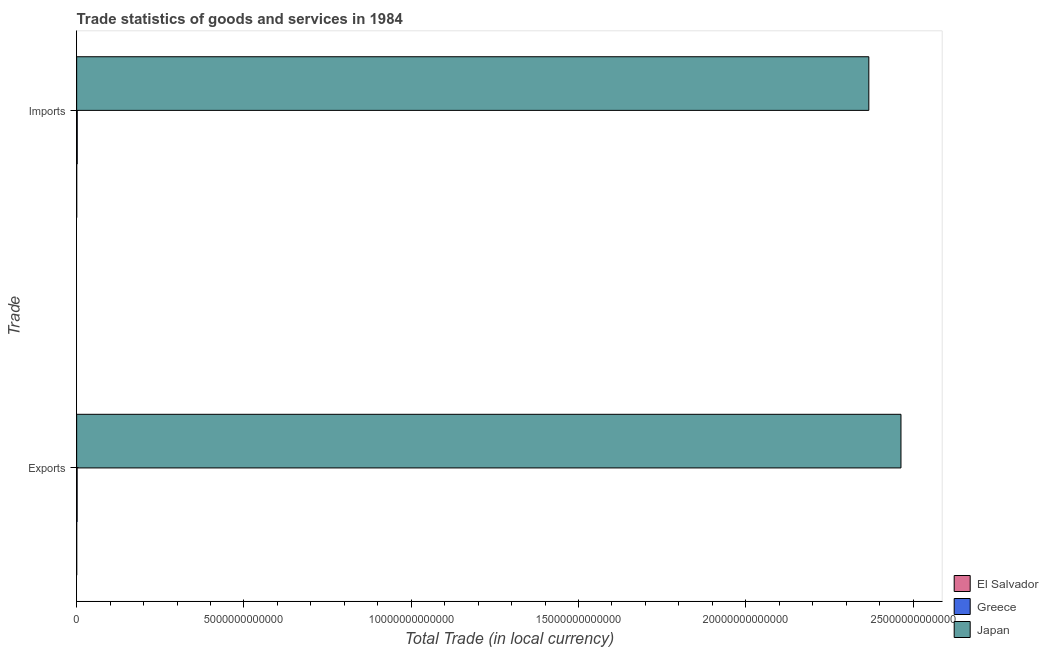How many groups of bars are there?
Offer a terse response. 2. How many bars are there on the 1st tick from the bottom?
Offer a very short reply. 3. What is the label of the 2nd group of bars from the top?
Make the answer very short. Exports. What is the export of goods and services in Greece?
Give a very brief answer. 1.41e+1. Across all countries, what is the maximum imports of goods and services?
Your answer should be very brief. 2.37e+13. Across all countries, what is the minimum imports of goods and services?
Offer a very short reply. 1.04e+09. In which country was the export of goods and services minimum?
Ensure brevity in your answer.  El Salvador. What is the total imports of goods and services in the graph?
Provide a short and direct response. 2.37e+13. What is the difference between the imports of goods and services in El Salvador and that in Greece?
Provide a succinct answer. -1.61e+1. What is the difference between the imports of goods and services in Greece and the export of goods and services in El Salvador?
Keep it short and to the point. 1.62e+1. What is the average export of goods and services per country?
Make the answer very short. 8.22e+12. What is the difference between the imports of goods and services and export of goods and services in Greece?
Your response must be concise. 3.04e+09. What is the ratio of the export of goods and services in Japan to that in El Salvador?
Make the answer very short. 2.49e+04. Is the imports of goods and services in Japan less than that in Greece?
Give a very brief answer. No. In how many countries, is the export of goods and services greater than the average export of goods and services taken over all countries?
Keep it short and to the point. 1. What does the 2nd bar from the top in Exports represents?
Give a very brief answer. Greece. What does the 1st bar from the bottom in Exports represents?
Your answer should be compact. El Salvador. How many countries are there in the graph?
Your answer should be very brief. 3. What is the difference between two consecutive major ticks on the X-axis?
Provide a short and direct response. 5.00e+12. Are the values on the major ticks of X-axis written in scientific E-notation?
Make the answer very short. No. How many legend labels are there?
Provide a succinct answer. 3. What is the title of the graph?
Ensure brevity in your answer.  Trade statistics of goods and services in 1984. Does "Congo (Democratic)" appear as one of the legend labels in the graph?
Make the answer very short. No. What is the label or title of the X-axis?
Offer a very short reply. Total Trade (in local currency). What is the label or title of the Y-axis?
Give a very brief answer. Trade. What is the Total Trade (in local currency) in El Salvador in Exports?
Make the answer very short. 9.90e+08. What is the Total Trade (in local currency) of Greece in Exports?
Offer a very short reply. 1.41e+1. What is the Total Trade (in local currency) in Japan in Exports?
Your answer should be very brief. 2.46e+13. What is the Total Trade (in local currency) of El Salvador in Imports?
Your answer should be very brief. 1.04e+09. What is the Total Trade (in local currency) of Greece in Imports?
Provide a short and direct response. 1.71e+1. What is the Total Trade (in local currency) of Japan in Imports?
Ensure brevity in your answer.  2.37e+13. Across all Trade, what is the maximum Total Trade (in local currency) in El Salvador?
Your response must be concise. 1.04e+09. Across all Trade, what is the maximum Total Trade (in local currency) of Greece?
Make the answer very short. 1.71e+1. Across all Trade, what is the maximum Total Trade (in local currency) in Japan?
Your answer should be compact. 2.46e+13. Across all Trade, what is the minimum Total Trade (in local currency) of El Salvador?
Your answer should be very brief. 9.90e+08. Across all Trade, what is the minimum Total Trade (in local currency) of Greece?
Make the answer very short. 1.41e+1. Across all Trade, what is the minimum Total Trade (in local currency) in Japan?
Offer a terse response. 2.37e+13. What is the total Total Trade (in local currency) in El Salvador in the graph?
Offer a very short reply. 2.03e+09. What is the total Total Trade (in local currency) of Greece in the graph?
Offer a very short reply. 3.12e+1. What is the total Total Trade (in local currency) in Japan in the graph?
Give a very brief answer. 4.83e+13. What is the difference between the Total Trade (in local currency) of El Salvador in Exports and that in Imports?
Provide a succinct answer. -5.29e+07. What is the difference between the Total Trade (in local currency) of Greece in Exports and that in Imports?
Your answer should be very brief. -3.04e+09. What is the difference between the Total Trade (in local currency) of Japan in Exports and that in Imports?
Your answer should be very brief. 9.61e+11. What is the difference between the Total Trade (in local currency) of El Salvador in Exports and the Total Trade (in local currency) of Greece in Imports?
Your answer should be compact. -1.62e+1. What is the difference between the Total Trade (in local currency) of El Salvador in Exports and the Total Trade (in local currency) of Japan in Imports?
Your answer should be compact. -2.37e+13. What is the difference between the Total Trade (in local currency) of Greece in Exports and the Total Trade (in local currency) of Japan in Imports?
Your answer should be compact. -2.37e+13. What is the average Total Trade (in local currency) of El Salvador per Trade?
Ensure brevity in your answer.  1.02e+09. What is the average Total Trade (in local currency) of Greece per Trade?
Provide a short and direct response. 1.56e+1. What is the average Total Trade (in local currency) of Japan per Trade?
Make the answer very short. 2.42e+13. What is the difference between the Total Trade (in local currency) of El Salvador and Total Trade (in local currency) of Greece in Exports?
Ensure brevity in your answer.  -1.31e+1. What is the difference between the Total Trade (in local currency) in El Salvador and Total Trade (in local currency) in Japan in Exports?
Keep it short and to the point. -2.46e+13. What is the difference between the Total Trade (in local currency) of Greece and Total Trade (in local currency) of Japan in Exports?
Your answer should be compact. -2.46e+13. What is the difference between the Total Trade (in local currency) of El Salvador and Total Trade (in local currency) of Greece in Imports?
Your answer should be compact. -1.61e+1. What is the difference between the Total Trade (in local currency) in El Salvador and Total Trade (in local currency) in Japan in Imports?
Provide a short and direct response. -2.37e+13. What is the difference between the Total Trade (in local currency) of Greece and Total Trade (in local currency) of Japan in Imports?
Make the answer very short. -2.37e+13. What is the ratio of the Total Trade (in local currency) of El Salvador in Exports to that in Imports?
Your answer should be very brief. 0.95. What is the ratio of the Total Trade (in local currency) of Greece in Exports to that in Imports?
Your response must be concise. 0.82. What is the ratio of the Total Trade (in local currency) in Japan in Exports to that in Imports?
Your answer should be compact. 1.04. What is the difference between the highest and the second highest Total Trade (in local currency) of El Salvador?
Ensure brevity in your answer.  5.29e+07. What is the difference between the highest and the second highest Total Trade (in local currency) in Greece?
Provide a short and direct response. 3.04e+09. What is the difference between the highest and the second highest Total Trade (in local currency) in Japan?
Ensure brevity in your answer.  9.61e+11. What is the difference between the highest and the lowest Total Trade (in local currency) in El Salvador?
Your response must be concise. 5.29e+07. What is the difference between the highest and the lowest Total Trade (in local currency) of Greece?
Provide a short and direct response. 3.04e+09. What is the difference between the highest and the lowest Total Trade (in local currency) in Japan?
Your answer should be very brief. 9.61e+11. 